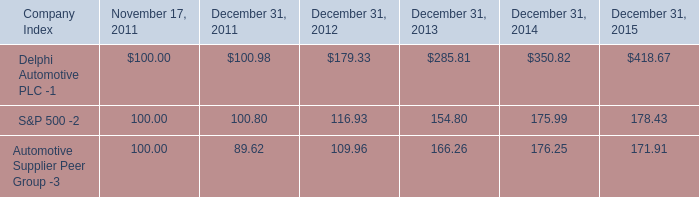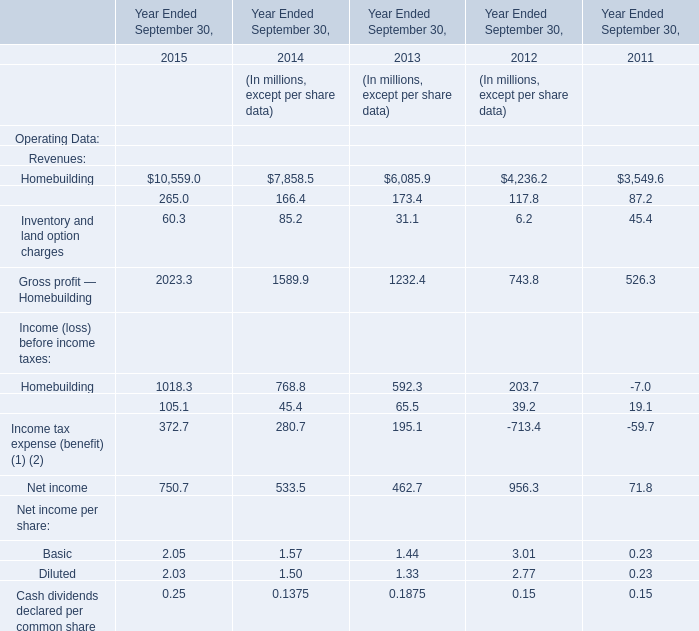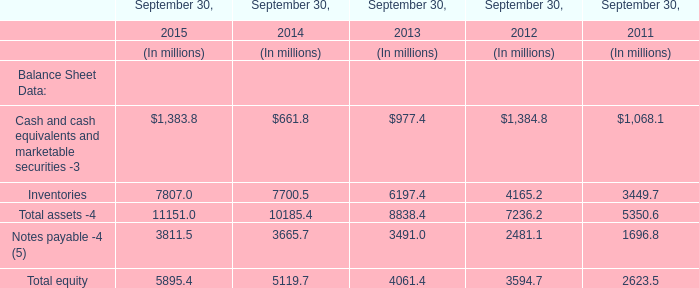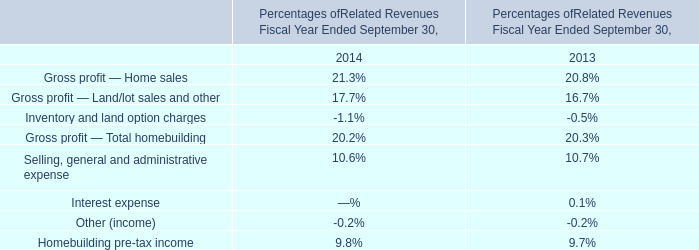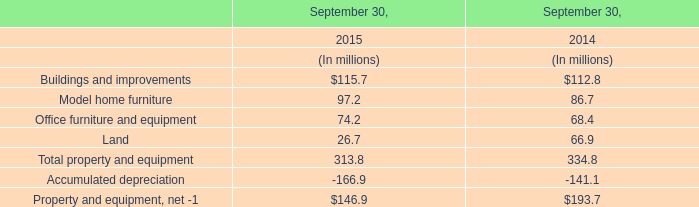What was the total amount of Inventories greater than 7000 in 2015? (in million) 
Computations: (7807.0 + 7700.5)
Answer: 15507.5. 